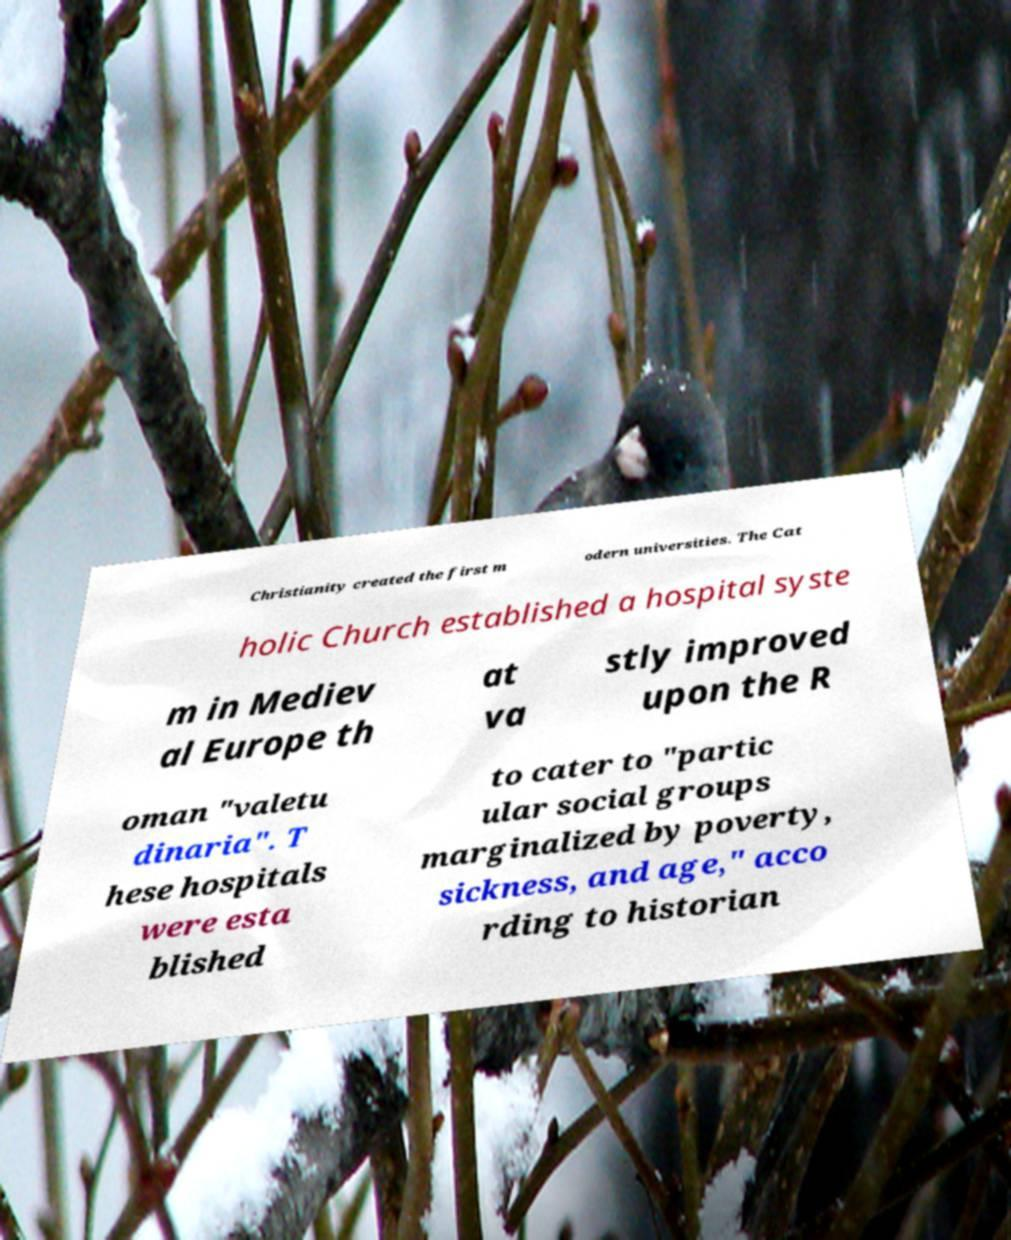Could you assist in decoding the text presented in this image and type it out clearly? Christianity created the first m odern universities. The Cat holic Church established a hospital syste m in Mediev al Europe th at va stly improved upon the R oman "valetu dinaria". T hese hospitals were esta blished to cater to "partic ular social groups marginalized by poverty, sickness, and age," acco rding to historian 